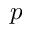<formula> <loc_0><loc_0><loc_500><loc_500>p</formula> 